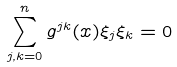Convert formula to latex. <formula><loc_0><loc_0><loc_500><loc_500>\sum _ { j , k = 0 } ^ { n } g ^ { j k } ( x ) \xi _ { j } \xi _ { k } = 0</formula> 